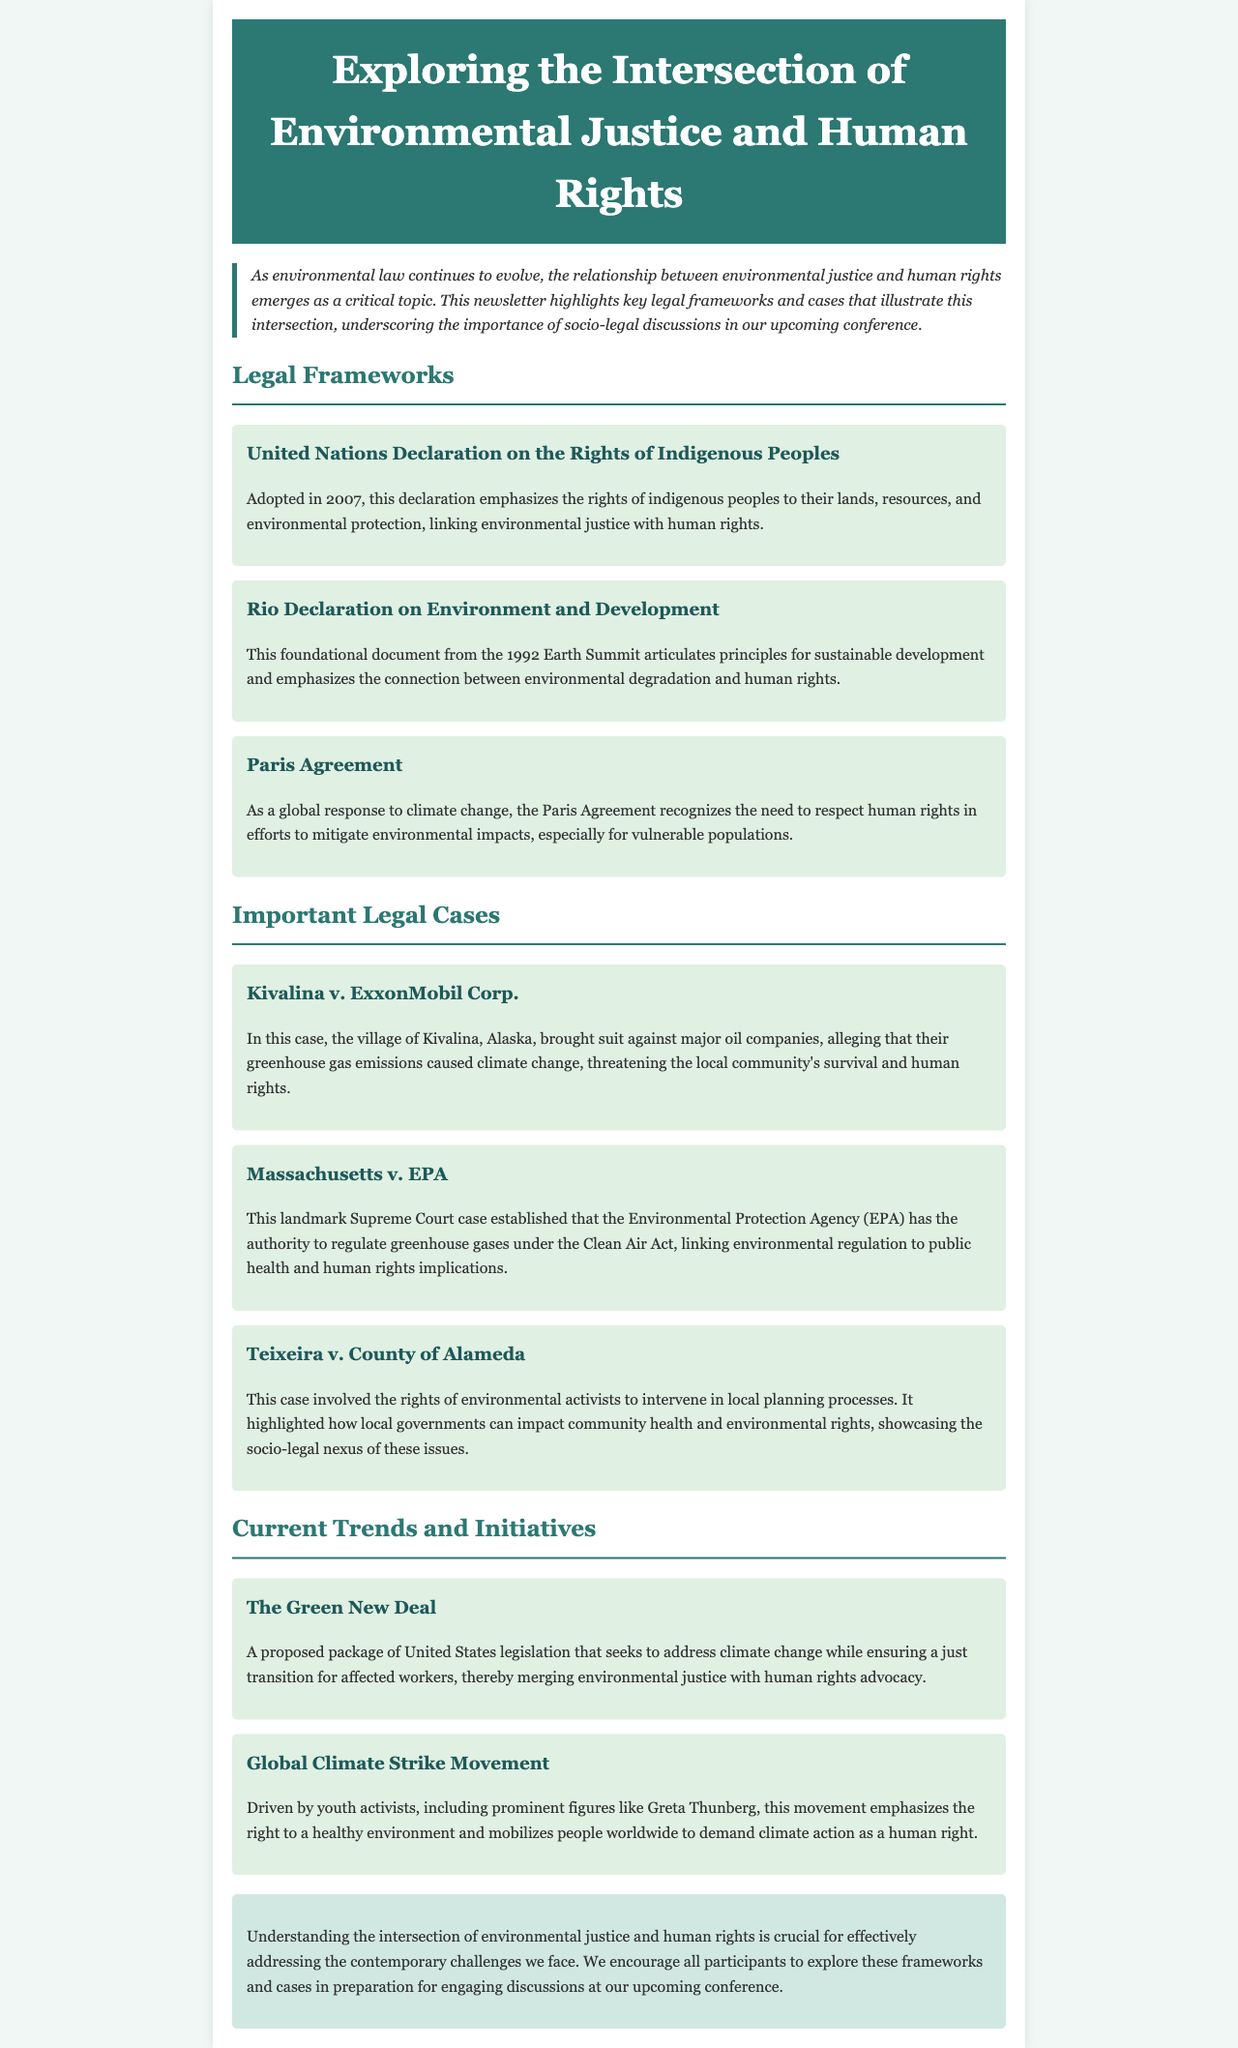What is the title of the newsletter? The title is presented at the top of the document, indicating the main theme of the newsletter.
Answer: Exploring the Intersection of Environmental Justice and Human Rights What year was the United Nations Declaration on the Rights of Indigenous Peoples adopted? The document specifies the adoption year of this important legal framework.
Answer: 2007 Which landmark Supreme Court case is mentioned? The newsletter includes a critical case that established EPA's authority under the Clean Air Act.
Answer: Massachusetts v. EPA What proposed package of legislation is mentioned that seeks to address climate change? The document highlights a legislative proposal aimed at merging environmental justice with human rights advocacy.
Answer: The Green New Deal Who is a prominent figure associated with the Global Climate Strike Movement? This question references the document's mention of a key activist within this global movement.
Answer: Greta Thunberg What is emphasized by the Rio Declaration on Environment and Development? The document summarizes key principles from this foundational environmental document.
Answer: Sustainable development and connection between environmental degradation and human rights In which section do we find important legal cases? The layout of the newsletter organizes content into specific sections, with legal cases highlighted separately.
Answer: Important Legal Cases What does the Paris Agreement recognize? This agreement's purpose is discussed in the context of its human rights implications amidst climate change efforts.
Answer: Need to respect human rights 